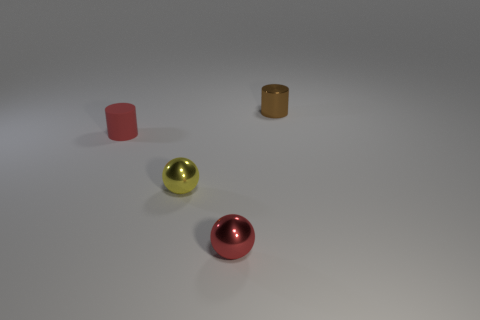Is the number of tiny yellow metal objects behind the red cylinder less than the number of red cylinders behind the tiny red shiny sphere? yes 